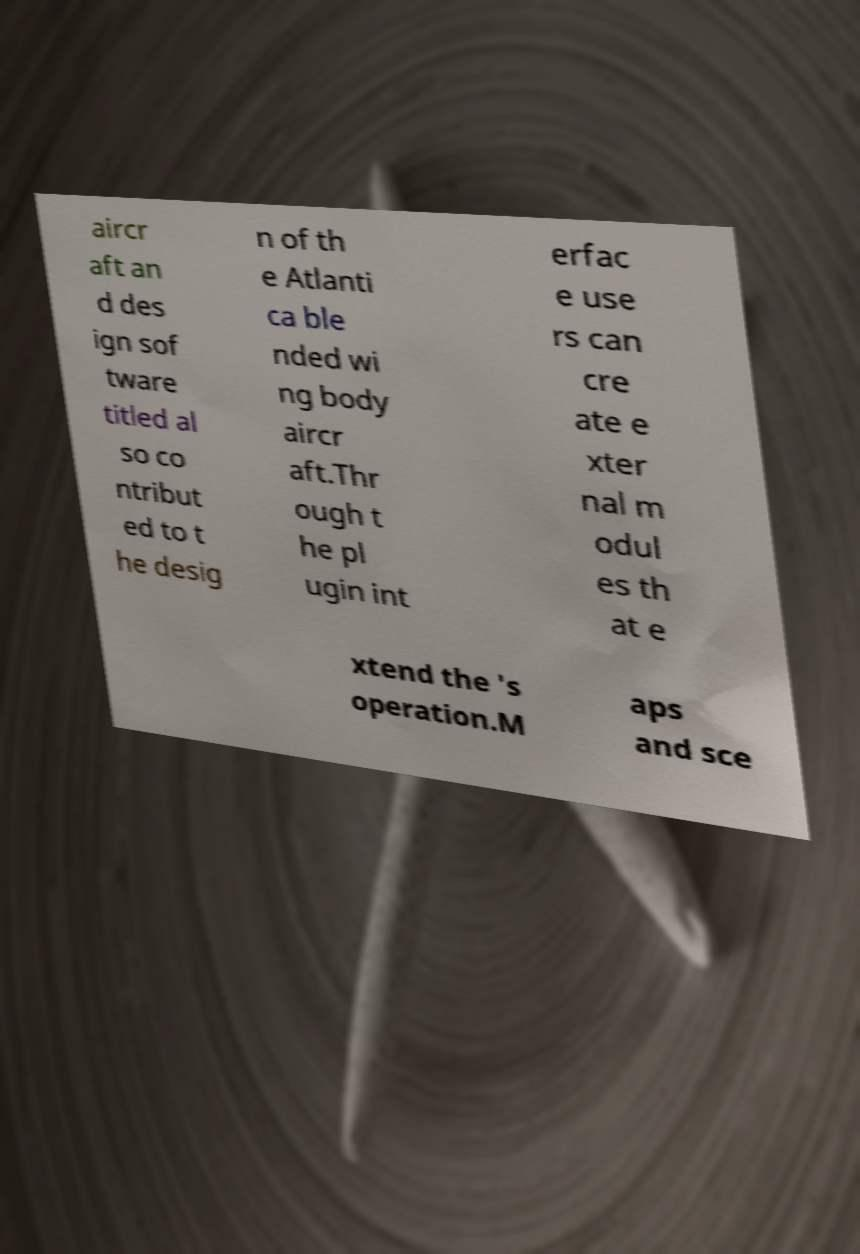Can you accurately transcribe the text from the provided image for me? aircr aft an d des ign sof tware titled al so co ntribut ed to t he desig n of th e Atlanti ca ble nded wi ng body aircr aft.Thr ough t he pl ugin int erfac e use rs can cre ate e xter nal m odul es th at e xtend the 's operation.M aps and sce 